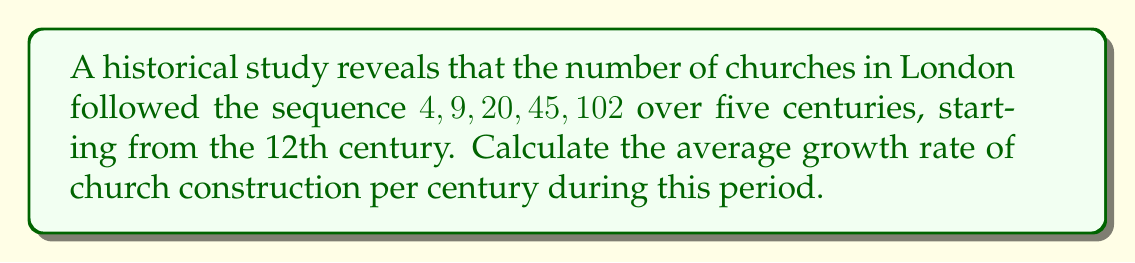Provide a solution to this math problem. To solve this problem, we'll follow these steps:

1. Calculate the growth factor between each pair of consecutive centuries:
   - 12th to 13th century: $\frac{9}{4} = 2.25$
   - 13th to 14th century: $\frac{20}{9} \approx 2.22$
   - 14th to 15th century: $\frac{45}{20} = 2.25$
   - 15th to 16th century: $\frac{102}{45} \approx 2.27$

2. Calculate the geometric mean of these growth factors:
   $$\sqrt[4]{2.25 \times 2.22 \times 2.25 \times 2.27} \approx 2.2474$$

3. Convert the growth factor to a percentage:
   $$(2.2474 - 1) \times 100\% \approx 124.74\%$$

This means that, on average, the number of churches increased by approximately 124.74% every century.
Answer: 124.74% 